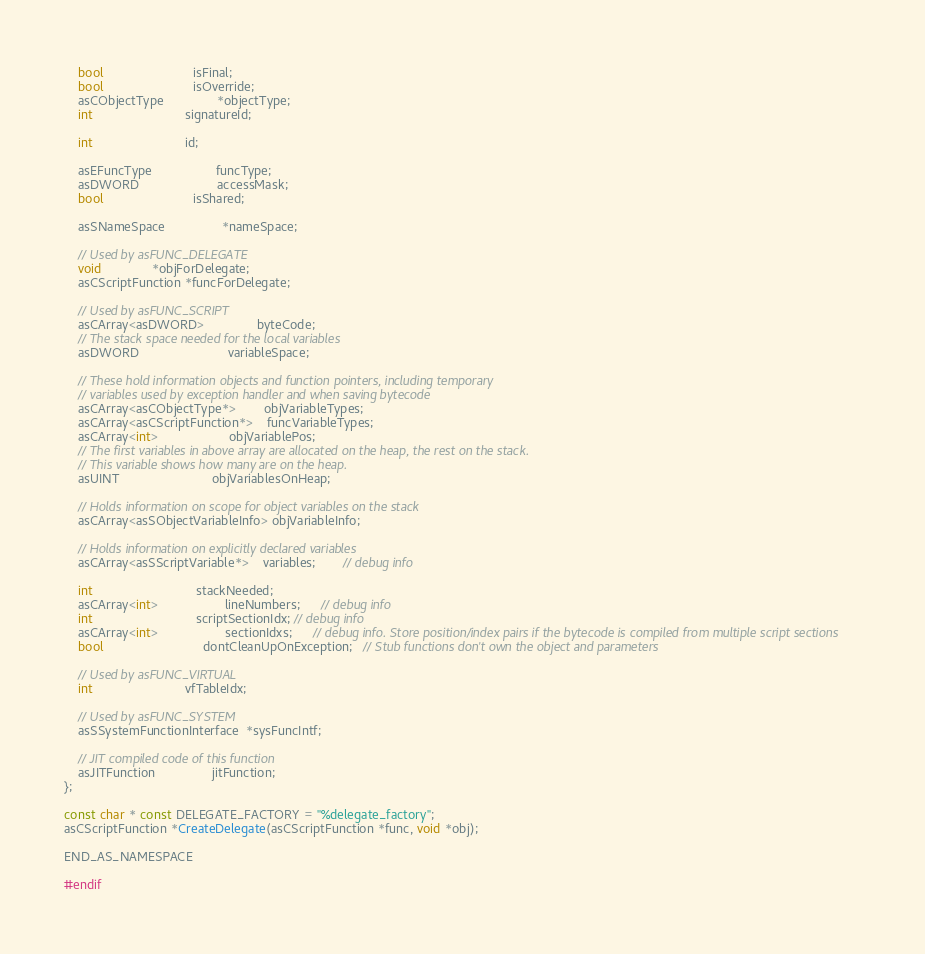Convert code to text. <code><loc_0><loc_0><loc_500><loc_500><_C_>	bool                         isFinal;
	bool                         isOverride;
	asCObjectType               *objectType;
	int                          signatureId;

	int                          id;

	asEFuncType                  funcType;
	asDWORD                      accessMask;
	bool                         isShared;

	asSNameSpace                *nameSpace;

	// Used by asFUNC_DELEGATE
	void              *objForDelegate;
	asCScriptFunction *funcForDelegate;

	// Used by asFUNC_SCRIPT
	asCArray<asDWORD>               byteCode;
	// The stack space needed for the local variables
	asDWORD                         variableSpace;

	// These hold information objects and function pointers, including temporary
	// variables used by exception handler and when saving bytecode
	asCArray<asCObjectType*>        objVariableTypes;
	asCArray<asCScriptFunction*>    funcVariableTypes;
	asCArray<int>	                objVariablePos;
	// The first variables in above array are allocated on the heap, the rest on the stack.
	// This variable shows how many are on the heap.
	asUINT                          objVariablesOnHeap;

	// Holds information on scope for object variables on the stack
	asCArray<asSObjectVariableInfo> objVariableInfo;

	// Holds information on explicitly declared variables
	asCArray<asSScriptVariable*>    variables;        // debug info

	int                             stackNeeded;
	asCArray<int>                   lineNumbers;      // debug info
	int                             scriptSectionIdx; // debug info
	asCArray<int>                   sectionIdxs;      // debug info. Store position/index pairs if the bytecode is compiled from multiple script sections
	bool                            dontCleanUpOnException;   // Stub functions don't own the object and parameters

	// Used by asFUNC_VIRTUAL
	int                          vfTableIdx;

	// Used by asFUNC_SYSTEM
	asSSystemFunctionInterface  *sysFuncIntf;

    // JIT compiled code of this function
    asJITFunction                jitFunction;
};

const char * const DELEGATE_FACTORY = "%delegate_factory";
asCScriptFunction *CreateDelegate(asCScriptFunction *func, void *obj);

END_AS_NAMESPACE

#endif
</code> 